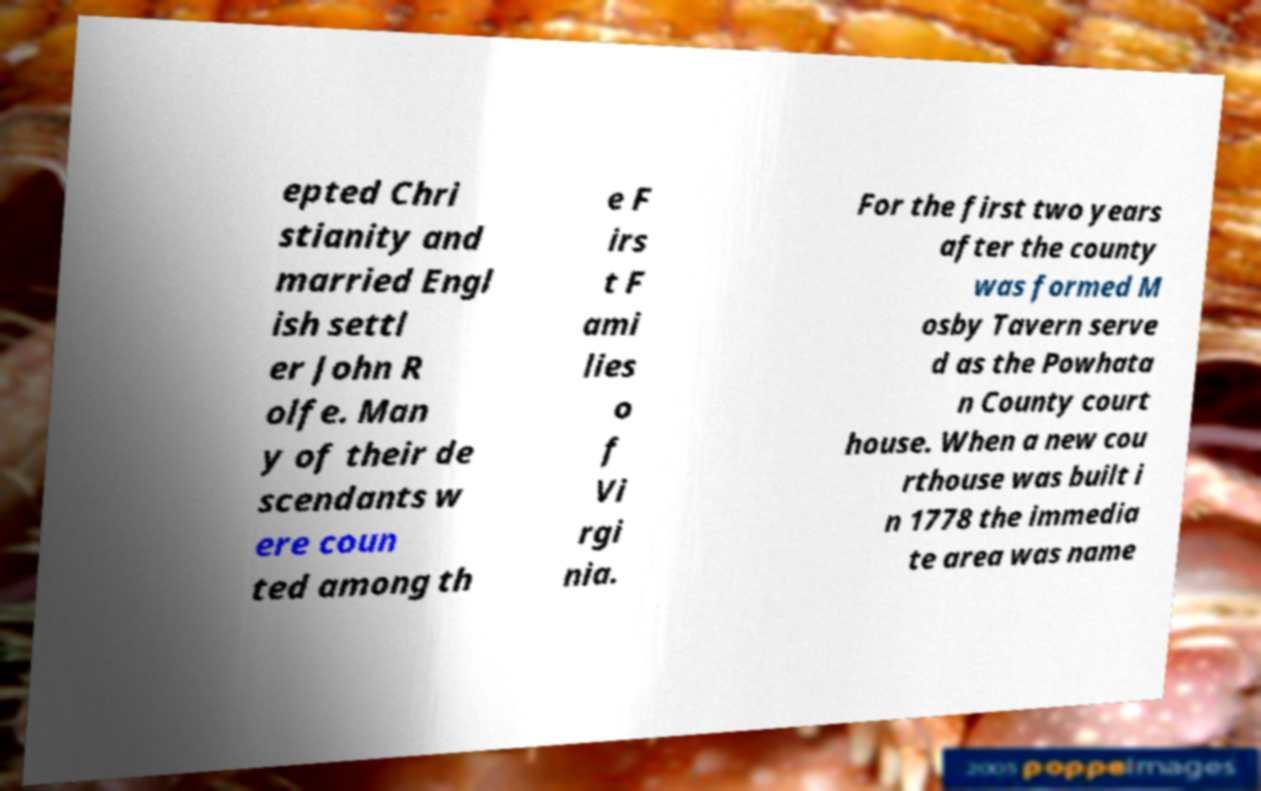Please identify and transcribe the text found in this image. epted Chri stianity and married Engl ish settl er John R olfe. Man y of their de scendants w ere coun ted among th e F irs t F ami lies o f Vi rgi nia. For the first two years after the county was formed M osby Tavern serve d as the Powhata n County court house. When a new cou rthouse was built i n 1778 the immedia te area was name 